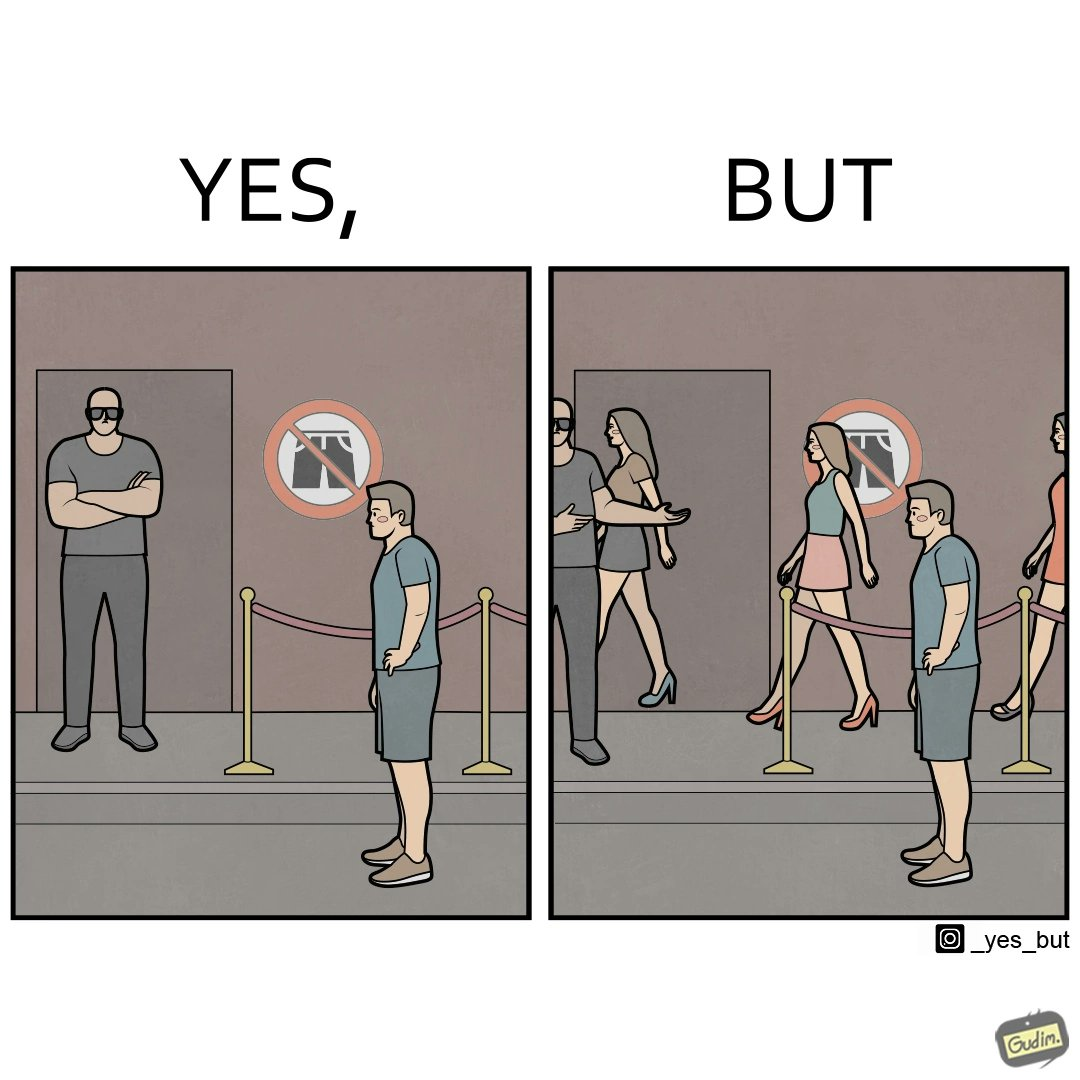Is this image satirical or non-satirical? Yes, this image is satirical. 